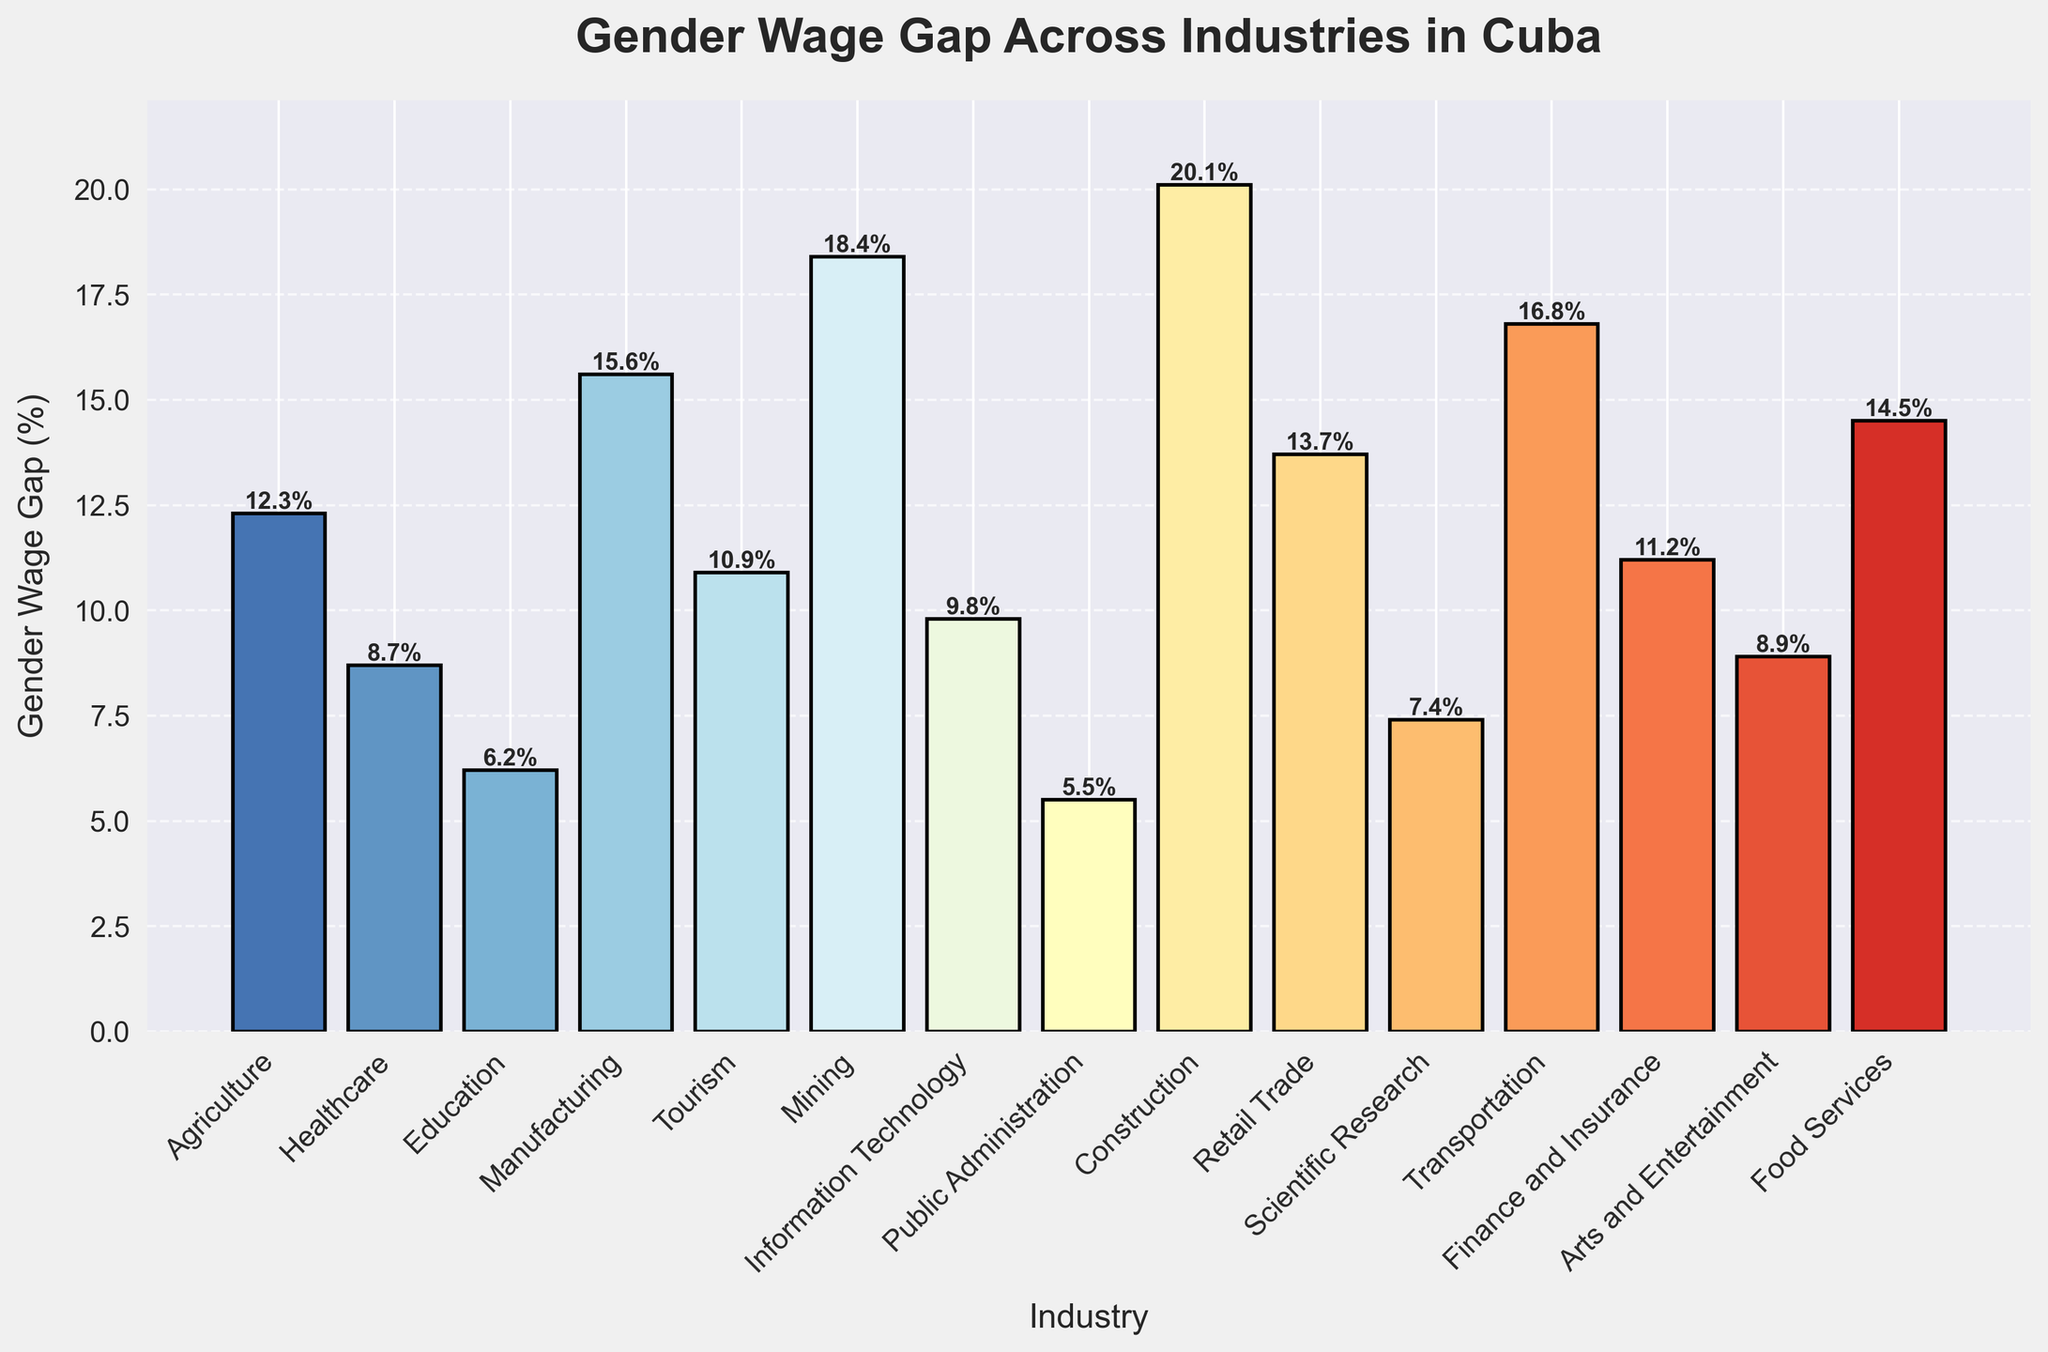Which industry has the highest gender wage gap and what is its percentage? The tallest bar represents the highest gender wage gap. The label indicates the industry and the percentage.
Answer: Construction, 20.1% Which industry has the smallest gender wage gap? The shortest bar indicates the smallest gender wage gap. The label on this bar shows the industry and percentage.
Answer: Public Administration, 5.5% What is the average gender wage gap across all industries? First, sum all the gender wage gap percentages, then divide by the number of industries: (12.3 + 8.7 + 6.2 + 15.6 + 10.9 + 18.4 + 9.8 + 5.5 + 20.1 + 13.7 + 7.4 + 16.8 + 11.2 + 8.9 + 14.5) / 15
Answer: 12.0% By how much does the gender wage gap in Manufacturing differ from Healthcare? Find the percentages for both industries and subtract the smaller value from the larger one: 15.6% (Manufacturing) - 8.7% (Healthcare)
Answer: 6.9% Which industry has a lower gender wage gap, Tourism or Scientific Research? Compare the height of the bars or the percentages: Tourism is 10.9%, Scientific Research is 7.4%.
Answer: Scientific Research What is the total gender wage gap percentage for all industries combined? Sum all the gender wage gap percentages: 12.3 + 8.7 + 6.2 + 15.6 + 10.9 + 18.4 + 9.8 + 5.5 + 20.1 + 13.7 + 7.4 + 16.8 + 11.2 + 8.9 + 14.5
Answer: 180.0% Which industries have a gender wage gap greater than 15%? Identify the bars taller than 15%, and note the industries and their percentages: Manufacturing (15.6%), Mining (18.4%), Construction (20.1%), Transportation (16.8%)
Answer: Manufacturing, Mining, Construction, Transportation How many industries have a gender wage gap of less than 10%? Count the bars that are shorter than the 10% mark: Healthcare (8.7%), Education (6.2%), Public Administration (5.5%), Scientific Research (7.4%), Arts and Entertainment (8.9%)
Answer: 5 